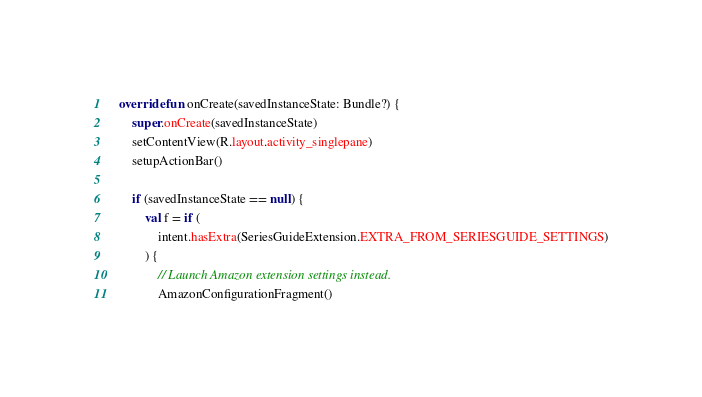Convert code to text. <code><loc_0><loc_0><loc_500><loc_500><_Kotlin_>
    override fun onCreate(savedInstanceState: Bundle?) {
        super.onCreate(savedInstanceState)
        setContentView(R.layout.activity_singlepane)
        setupActionBar()

        if (savedInstanceState == null) {
            val f = if (
                intent.hasExtra(SeriesGuideExtension.EXTRA_FROM_SERIESGUIDE_SETTINGS)
            ) {
                // Launch Amazon extension settings instead.
                AmazonConfigurationFragment()</code> 